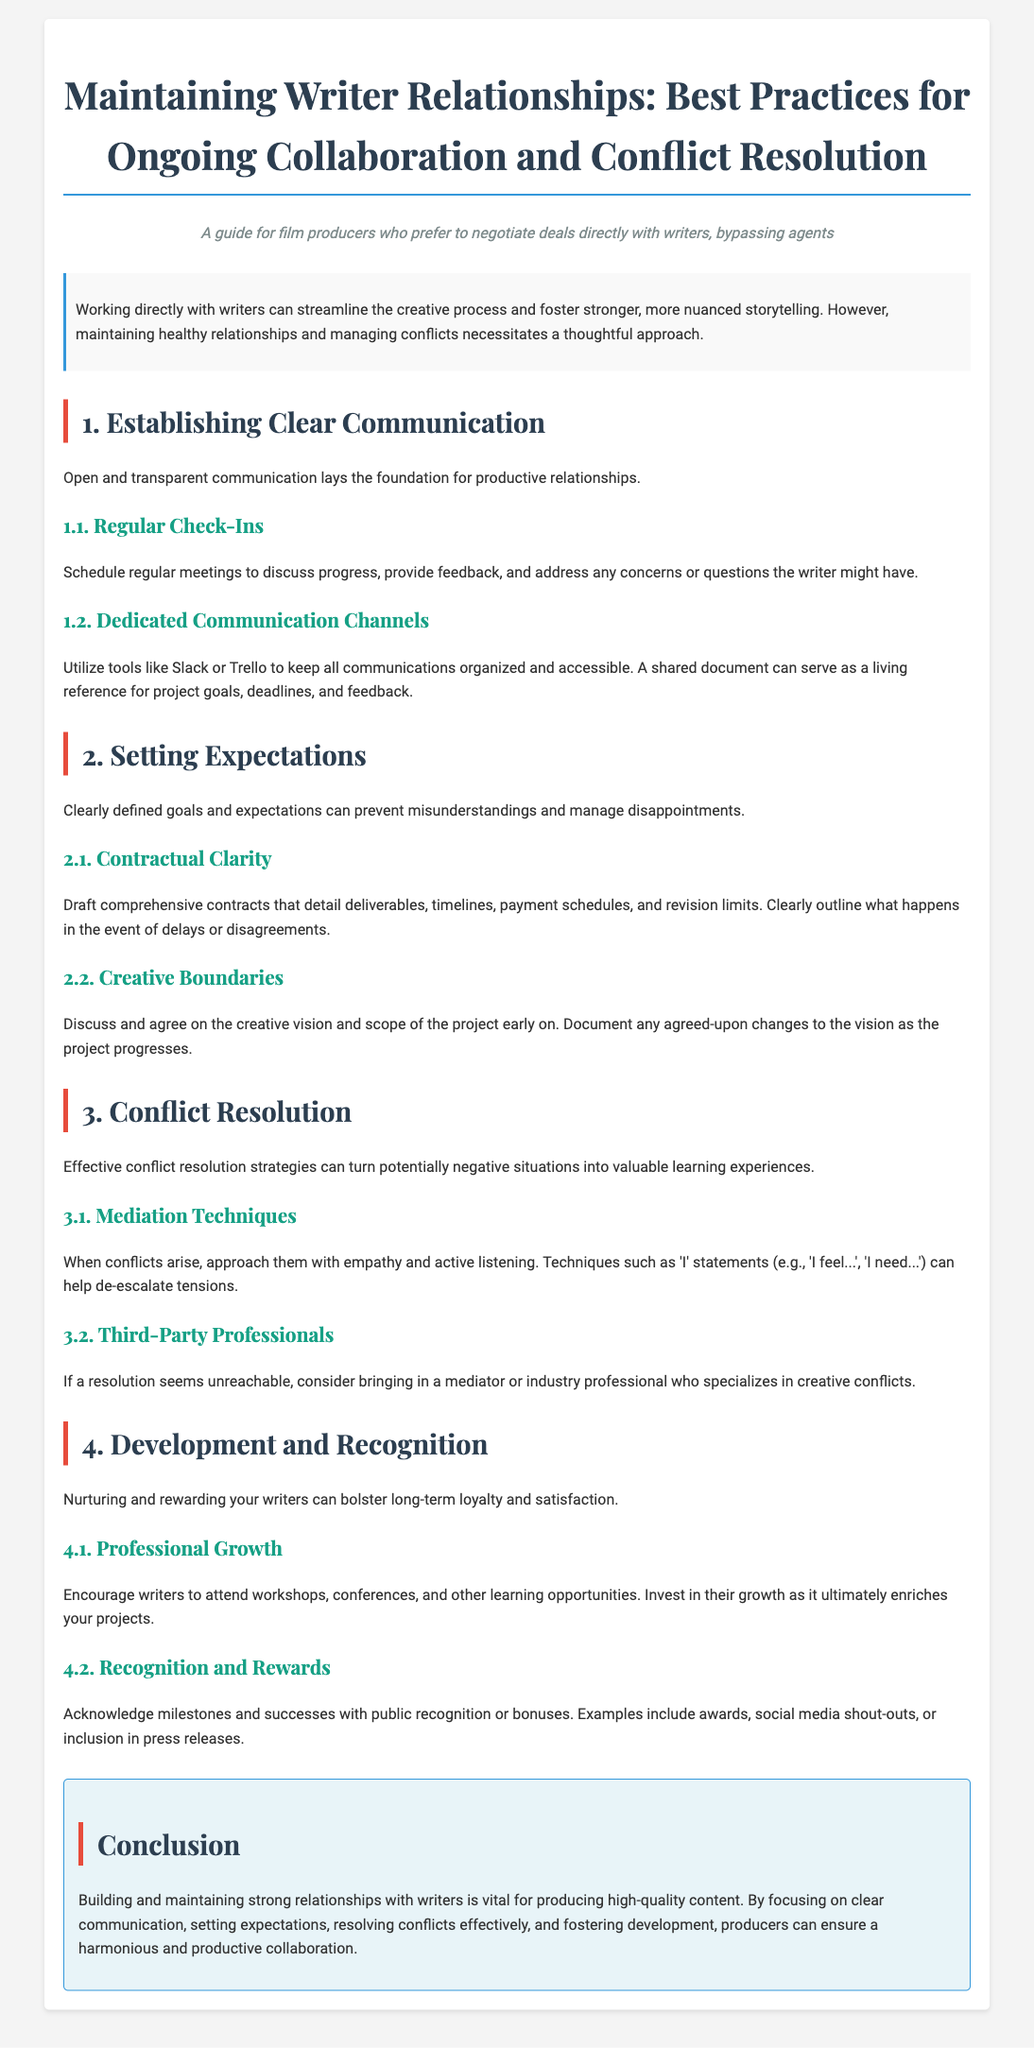what is the main purpose of this guide? The main purpose is to help film producers maintain healthy relationships with writers for effective collaboration and conflict resolution.
Answer: to help film producers maintain healthy relationships with writers how many main sections are in the document? The document is divided into four main sections: Establishing Clear Communication, Setting Expectations, Conflict Resolution, and Development and Recognition.
Answer: four what is suggested for communication channels? The document suggests utilizing tools like Slack or Trello for organization and accessibility of communications.
Answer: Slack or Trello what technique is recommended for approaching conflicts? It is recommended to use empathy and active listening techniques, such as 'I' statements, to address conflicts.
Answer: 'I' statements what should be included in comprehensive contracts? Comprehensive contracts should detail deliverables, timelines, payment schedules, and revision limits to avoid misunderstandings.
Answer: deliverables, timelines, payment schedules, and revision limits which section focuses on nurturing writers? The section dedicated to Professional Growth and Recognition covers the nurturing of writers and their contributions.
Answer: Development and Recognition when should regular meetings be scheduled? Regular meetings should be scheduled to discuss progress and address any concerns the writer might have at specified intervals during the project.
Answer: regularly what can help de-escalate tensions? Techniques such as using 'I' statements can help de-escalate tensions during conflicts.
Answer: 'I' statements what is a benefit of encouraging writers to attend workshops? Encouraging writers to attend workshops will enrich not only their skills but also the overall quality of your projects.
Answer: enriches your projects 